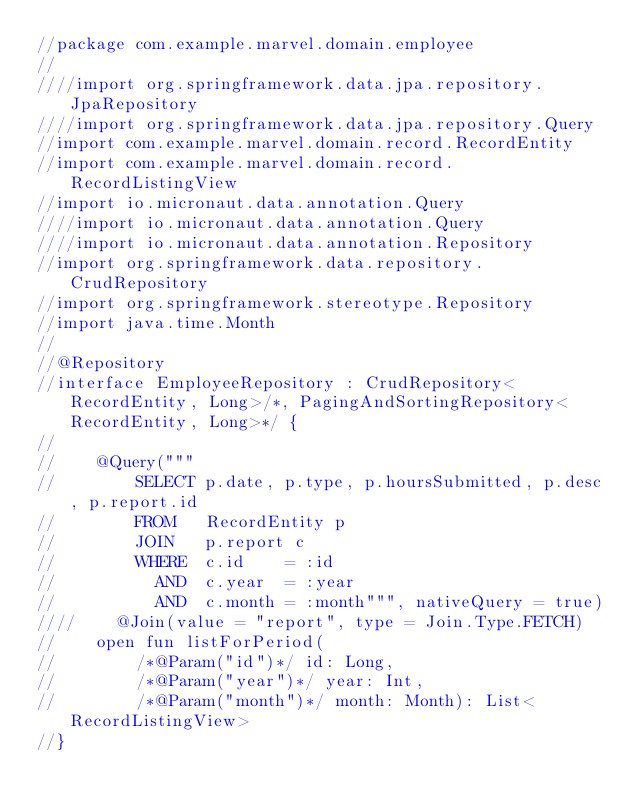Convert code to text. <code><loc_0><loc_0><loc_500><loc_500><_Kotlin_>//package com.example.marvel.domain.employee
//
////import org.springframework.data.jpa.repository.JpaRepository
////import org.springframework.data.jpa.repository.Query
//import com.example.marvel.domain.record.RecordEntity
//import com.example.marvel.domain.record.RecordListingView
//import io.micronaut.data.annotation.Query
////import io.micronaut.data.annotation.Query
////import io.micronaut.data.annotation.Repository
//import org.springframework.data.repository.CrudRepository
//import org.springframework.stereotype.Repository
//import java.time.Month
//
//@Repository
//interface EmployeeRepository : CrudRepository<RecordEntity, Long>/*, PagingAndSortingRepository<RecordEntity, Long>*/ {
//
//    @Query("""
//        SELECT p.date, p.type, p.hoursSubmitted, p.desc, p.report.id
//        FROM   RecordEntity p
//        JOIN   p.report c
//        WHERE  c.id    = :id
//          AND  c.year  = :year
//          AND  c.month = :month""", nativeQuery = true)
////    @Join(value = "report", type = Join.Type.FETCH)
//    open fun listForPeriod(
//        /*@Param("id")*/ id: Long,
//        /*@Param("year")*/ year: Int,
//        /*@Param("month")*/ month: Month): List<RecordListingView>
//}
</code> 